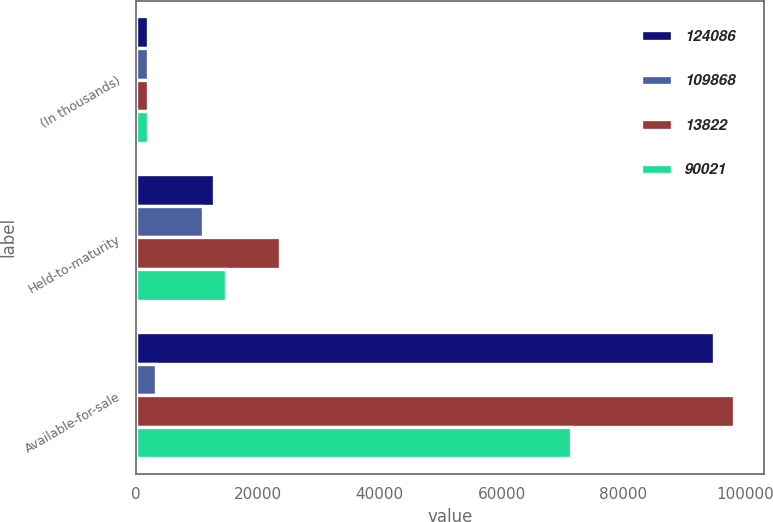<chart> <loc_0><loc_0><loc_500><loc_500><stacked_bar_chart><ecel><fcel>(In thousands)<fcel>Held-to-maturity<fcel>Available-for-sale<nl><fcel>124086<fcel>2015<fcel>12777<fcel>94877<nl><fcel>109868<fcel>2015<fcel>10892<fcel>3326<nl><fcel>13822<fcel>2015<fcel>23669<fcel>98203<nl><fcel>90021<fcel>2014<fcel>14770<fcel>71365<nl></chart> 